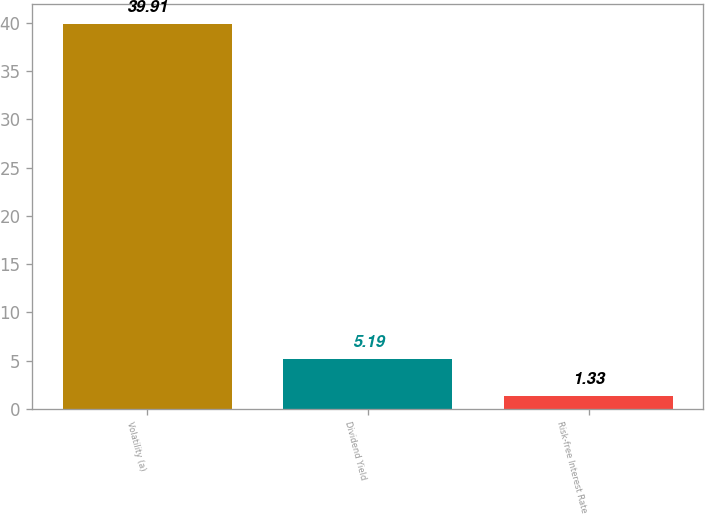<chart> <loc_0><loc_0><loc_500><loc_500><bar_chart><fcel>Volatility (a)<fcel>Dividend Yield<fcel>Risk-free Interest Rate<nl><fcel>39.91<fcel>5.19<fcel>1.33<nl></chart> 